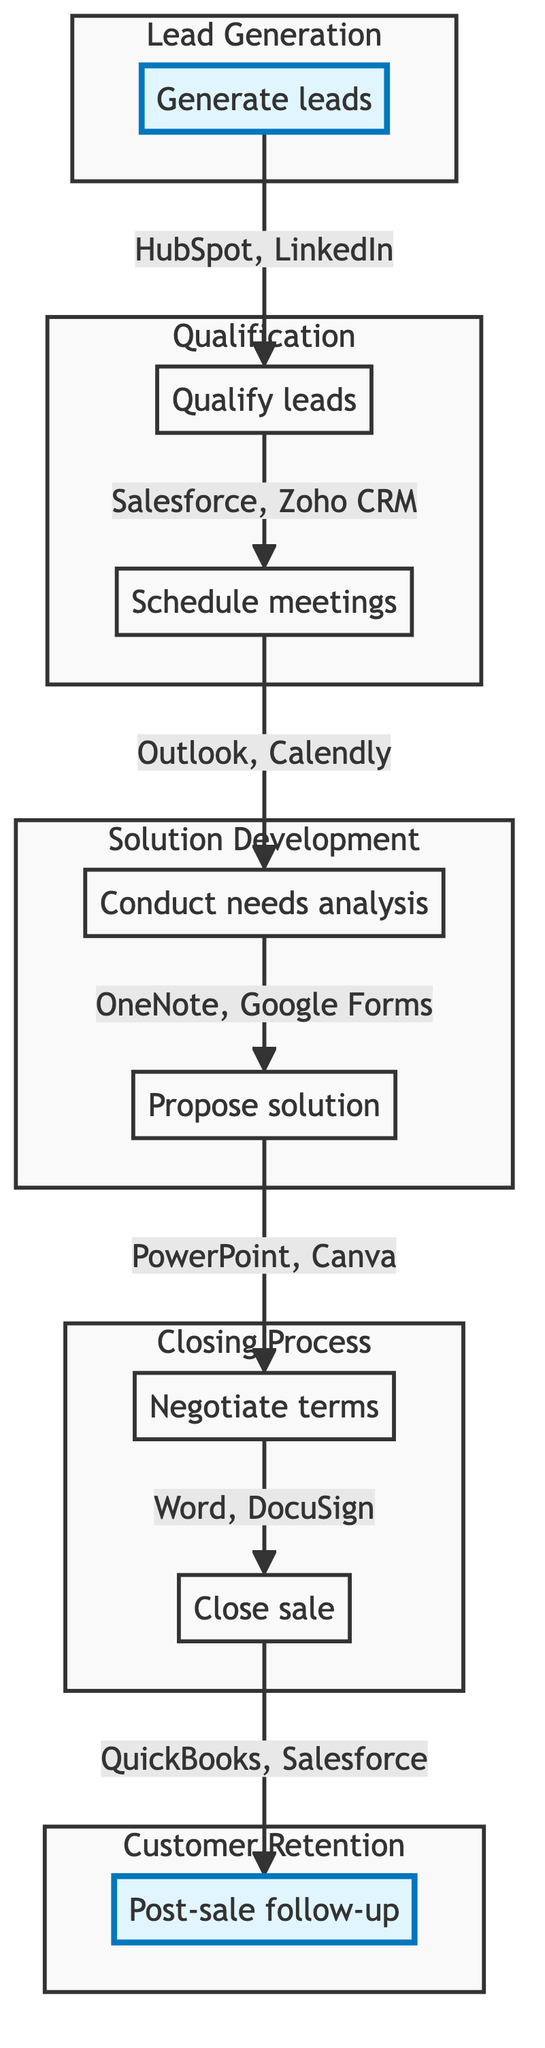What is the first step in the sales funnel process? The diagram clearly indicates that the first step is "Generate leads," as it is the starting point of the flowchart and connected to subsequent steps.
Answer: Generate leads How many main steps are there in the sales funnel process? By counting each of the distinct steps labeled in the diagram, we find that there are eight main steps represented from "Generate leads" to "Post-sale follow-up."
Answer: Eight Which step comes after conducting needs analysis? Looking at the flowchart, the arrow indicates that after "Conduct needs analysis," the next step is "Propose solution," establishing a clear sequence.
Answer: Propose solution What tools are used for scheduling meetings? The tools listed in the "Schedule meetings" step include Microsoft Outlook, Calendly, and Zoom, all underlined in that section of the diagram.
Answer: Microsoft Outlook, Calendly, Zoom What is the final step in the sales funnel process? The diagram shows that the last step is "Post-sale follow-up," which is clearly marked at the end of the flow of steps, representing customer retention.
Answer: Post-sale follow-up Which two steps are grouped under the "Solution Development" subgraph? By examining the "Solution Development" subgraph, it contains "Conduct needs analysis" and "Propose solution," showing their relatedness in this phase of the process.
Answer: Conduct needs analysis, Propose solution How do you qualify leads according to the diagram? The diagram specifies that to qualify leads, activities like analyzing lead data, segmenting leads based on criteria, and conducting preliminary discussions must be performed, indicating the detailed approach taken.
Answer: Analyze lead data, segment leads, conduct preliminary discussions What tools are associated with negotiating terms? The tools for the "Negotiate terms" step mentioned in the diagram include Microsoft Word, DocuSign, and Adobe Acrobat, identifying the resources needed during this part of the process.
Answer: Microsoft Word, DocuSign, Adobe Acrobat 